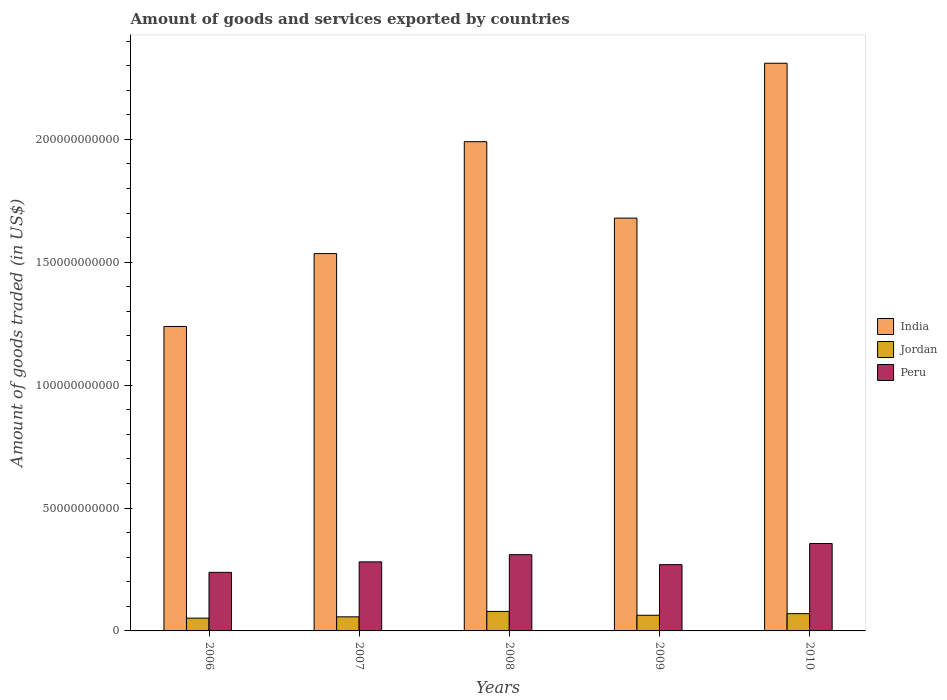How many different coloured bars are there?
Give a very brief answer. 3. Are the number of bars per tick equal to the number of legend labels?
Give a very brief answer. Yes. How many bars are there on the 3rd tick from the right?
Ensure brevity in your answer.  3. What is the label of the 1st group of bars from the left?
Give a very brief answer. 2006. What is the total amount of goods and services exported in India in 2006?
Your answer should be very brief. 1.24e+11. Across all years, what is the maximum total amount of goods and services exported in India?
Your response must be concise. 2.31e+11. Across all years, what is the minimum total amount of goods and services exported in Peru?
Make the answer very short. 2.38e+1. In which year was the total amount of goods and services exported in India maximum?
Your answer should be compact. 2010. In which year was the total amount of goods and services exported in India minimum?
Your answer should be very brief. 2006. What is the total total amount of goods and services exported in India in the graph?
Offer a terse response. 8.75e+11. What is the difference between the total amount of goods and services exported in India in 2008 and that in 2010?
Keep it short and to the point. -3.19e+1. What is the difference between the total amount of goods and services exported in Peru in 2007 and the total amount of goods and services exported in India in 2008?
Your response must be concise. -1.71e+11. What is the average total amount of goods and services exported in Jordan per year?
Provide a short and direct response. 6.46e+09. In the year 2006, what is the difference between the total amount of goods and services exported in Jordan and total amount of goods and services exported in Peru?
Give a very brief answer. -1.86e+1. In how many years, is the total amount of goods and services exported in India greater than 110000000000 US$?
Make the answer very short. 5. What is the ratio of the total amount of goods and services exported in India in 2006 to that in 2008?
Give a very brief answer. 0.62. Is the total amount of goods and services exported in India in 2006 less than that in 2010?
Offer a terse response. Yes. Is the difference between the total amount of goods and services exported in Jordan in 2006 and 2010 greater than the difference between the total amount of goods and services exported in Peru in 2006 and 2010?
Your answer should be compact. Yes. What is the difference between the highest and the second highest total amount of goods and services exported in Jordan?
Provide a succinct answer. 9.09e+08. What is the difference between the highest and the lowest total amount of goods and services exported in Jordan?
Keep it short and to the point. 2.73e+09. Is the sum of the total amount of goods and services exported in Jordan in 2006 and 2008 greater than the maximum total amount of goods and services exported in India across all years?
Offer a very short reply. No. What does the 3rd bar from the right in 2008 represents?
Keep it short and to the point. India. Is it the case that in every year, the sum of the total amount of goods and services exported in Jordan and total amount of goods and services exported in Peru is greater than the total amount of goods and services exported in India?
Ensure brevity in your answer.  No. How many bars are there?
Your response must be concise. 15. Are all the bars in the graph horizontal?
Offer a terse response. No. How many years are there in the graph?
Offer a terse response. 5. What is the difference between two consecutive major ticks on the Y-axis?
Your answer should be very brief. 5.00e+1. Where does the legend appear in the graph?
Your response must be concise. Center right. What is the title of the graph?
Keep it short and to the point. Amount of goods and services exported by countries. Does "Djibouti" appear as one of the legend labels in the graph?
Offer a very short reply. No. What is the label or title of the X-axis?
Offer a very short reply. Years. What is the label or title of the Y-axis?
Offer a very short reply. Amount of goods traded (in US$). What is the Amount of goods traded (in US$) of India in 2006?
Your response must be concise. 1.24e+11. What is the Amount of goods traded (in US$) of Jordan in 2006?
Your answer should be very brief. 5.20e+09. What is the Amount of goods traded (in US$) in Peru in 2006?
Offer a terse response. 2.38e+1. What is the Amount of goods traded (in US$) of India in 2007?
Your response must be concise. 1.54e+11. What is the Amount of goods traded (in US$) in Jordan in 2007?
Make the answer very short. 5.73e+09. What is the Amount of goods traded (in US$) in Peru in 2007?
Your answer should be compact. 2.81e+1. What is the Amount of goods traded (in US$) of India in 2008?
Your answer should be compact. 1.99e+11. What is the Amount of goods traded (in US$) of Jordan in 2008?
Provide a short and direct response. 7.94e+09. What is the Amount of goods traded (in US$) in Peru in 2008?
Provide a succinct answer. 3.10e+1. What is the Amount of goods traded (in US$) in India in 2009?
Offer a terse response. 1.68e+11. What is the Amount of goods traded (in US$) in Jordan in 2009?
Provide a short and direct response. 6.38e+09. What is the Amount of goods traded (in US$) of Peru in 2009?
Offer a very short reply. 2.70e+1. What is the Amount of goods traded (in US$) of India in 2010?
Offer a very short reply. 2.31e+11. What is the Amount of goods traded (in US$) in Jordan in 2010?
Provide a succinct answer. 7.03e+09. What is the Amount of goods traded (in US$) in Peru in 2010?
Keep it short and to the point. 3.56e+1. Across all years, what is the maximum Amount of goods traded (in US$) of India?
Your answer should be compact. 2.31e+11. Across all years, what is the maximum Amount of goods traded (in US$) of Jordan?
Offer a terse response. 7.94e+09. Across all years, what is the maximum Amount of goods traded (in US$) of Peru?
Offer a terse response. 3.56e+1. Across all years, what is the minimum Amount of goods traded (in US$) of India?
Keep it short and to the point. 1.24e+11. Across all years, what is the minimum Amount of goods traded (in US$) of Jordan?
Keep it short and to the point. 5.20e+09. Across all years, what is the minimum Amount of goods traded (in US$) in Peru?
Make the answer very short. 2.38e+1. What is the total Amount of goods traded (in US$) of India in the graph?
Offer a terse response. 8.75e+11. What is the total Amount of goods traded (in US$) of Jordan in the graph?
Your answer should be compact. 3.23e+1. What is the total Amount of goods traded (in US$) in Peru in the graph?
Keep it short and to the point. 1.45e+11. What is the difference between the Amount of goods traded (in US$) in India in 2006 and that in 2007?
Keep it short and to the point. -2.97e+1. What is the difference between the Amount of goods traded (in US$) of Jordan in 2006 and that in 2007?
Your answer should be very brief. -5.27e+08. What is the difference between the Amount of goods traded (in US$) of Peru in 2006 and that in 2007?
Provide a succinct answer. -4.26e+09. What is the difference between the Amount of goods traded (in US$) in India in 2006 and that in 2008?
Offer a terse response. -7.52e+1. What is the difference between the Amount of goods traded (in US$) of Jordan in 2006 and that in 2008?
Provide a short and direct response. -2.73e+09. What is the difference between the Amount of goods traded (in US$) of Peru in 2006 and that in 2008?
Provide a succinct answer. -7.19e+09. What is the difference between the Amount of goods traded (in US$) in India in 2006 and that in 2009?
Your response must be concise. -4.41e+1. What is the difference between the Amount of goods traded (in US$) of Jordan in 2006 and that in 2009?
Give a very brief answer. -1.17e+09. What is the difference between the Amount of goods traded (in US$) in Peru in 2006 and that in 2009?
Keep it short and to the point. -3.13e+09. What is the difference between the Amount of goods traded (in US$) of India in 2006 and that in 2010?
Offer a very short reply. -1.07e+11. What is the difference between the Amount of goods traded (in US$) of Jordan in 2006 and that in 2010?
Offer a terse response. -1.82e+09. What is the difference between the Amount of goods traded (in US$) in Peru in 2006 and that in 2010?
Provide a succinct answer. -1.17e+1. What is the difference between the Amount of goods traded (in US$) of India in 2007 and that in 2008?
Make the answer very short. -4.55e+1. What is the difference between the Amount of goods traded (in US$) of Jordan in 2007 and that in 2008?
Offer a terse response. -2.21e+09. What is the difference between the Amount of goods traded (in US$) in Peru in 2007 and that in 2008?
Keep it short and to the point. -2.92e+09. What is the difference between the Amount of goods traded (in US$) of India in 2007 and that in 2009?
Provide a short and direct response. -1.44e+1. What is the difference between the Amount of goods traded (in US$) of Jordan in 2007 and that in 2009?
Your response must be concise. -6.44e+08. What is the difference between the Amount of goods traded (in US$) in Peru in 2007 and that in 2009?
Ensure brevity in your answer.  1.13e+09. What is the difference between the Amount of goods traded (in US$) of India in 2007 and that in 2010?
Offer a terse response. -7.74e+1. What is the difference between the Amount of goods traded (in US$) of Jordan in 2007 and that in 2010?
Your answer should be compact. -1.30e+09. What is the difference between the Amount of goods traded (in US$) of Peru in 2007 and that in 2010?
Give a very brief answer. -7.47e+09. What is the difference between the Amount of goods traded (in US$) of India in 2008 and that in 2009?
Give a very brief answer. 3.11e+1. What is the difference between the Amount of goods traded (in US$) in Jordan in 2008 and that in 2009?
Ensure brevity in your answer.  1.56e+09. What is the difference between the Amount of goods traded (in US$) of Peru in 2008 and that in 2009?
Keep it short and to the point. 4.06e+09. What is the difference between the Amount of goods traded (in US$) in India in 2008 and that in 2010?
Keep it short and to the point. -3.19e+1. What is the difference between the Amount of goods traded (in US$) of Jordan in 2008 and that in 2010?
Offer a very short reply. 9.09e+08. What is the difference between the Amount of goods traded (in US$) in Peru in 2008 and that in 2010?
Your answer should be very brief. -4.55e+09. What is the difference between the Amount of goods traded (in US$) of India in 2009 and that in 2010?
Keep it short and to the point. -6.30e+1. What is the difference between the Amount of goods traded (in US$) in Jordan in 2009 and that in 2010?
Keep it short and to the point. -6.53e+08. What is the difference between the Amount of goods traded (in US$) of Peru in 2009 and that in 2010?
Provide a short and direct response. -8.60e+09. What is the difference between the Amount of goods traded (in US$) in India in 2006 and the Amount of goods traded (in US$) in Jordan in 2007?
Provide a short and direct response. 1.18e+11. What is the difference between the Amount of goods traded (in US$) of India in 2006 and the Amount of goods traded (in US$) of Peru in 2007?
Offer a very short reply. 9.58e+1. What is the difference between the Amount of goods traded (in US$) of Jordan in 2006 and the Amount of goods traded (in US$) of Peru in 2007?
Your answer should be very brief. -2.29e+1. What is the difference between the Amount of goods traded (in US$) of India in 2006 and the Amount of goods traded (in US$) of Jordan in 2008?
Offer a terse response. 1.16e+11. What is the difference between the Amount of goods traded (in US$) in India in 2006 and the Amount of goods traded (in US$) in Peru in 2008?
Your answer should be very brief. 9.29e+1. What is the difference between the Amount of goods traded (in US$) in Jordan in 2006 and the Amount of goods traded (in US$) in Peru in 2008?
Give a very brief answer. -2.58e+1. What is the difference between the Amount of goods traded (in US$) of India in 2006 and the Amount of goods traded (in US$) of Jordan in 2009?
Provide a short and direct response. 1.18e+11. What is the difference between the Amount of goods traded (in US$) of India in 2006 and the Amount of goods traded (in US$) of Peru in 2009?
Provide a succinct answer. 9.69e+1. What is the difference between the Amount of goods traded (in US$) of Jordan in 2006 and the Amount of goods traded (in US$) of Peru in 2009?
Provide a short and direct response. -2.18e+1. What is the difference between the Amount of goods traded (in US$) in India in 2006 and the Amount of goods traded (in US$) in Jordan in 2010?
Your response must be concise. 1.17e+11. What is the difference between the Amount of goods traded (in US$) of India in 2006 and the Amount of goods traded (in US$) of Peru in 2010?
Offer a terse response. 8.83e+1. What is the difference between the Amount of goods traded (in US$) in Jordan in 2006 and the Amount of goods traded (in US$) in Peru in 2010?
Make the answer very short. -3.04e+1. What is the difference between the Amount of goods traded (in US$) of India in 2007 and the Amount of goods traded (in US$) of Jordan in 2008?
Make the answer very short. 1.46e+11. What is the difference between the Amount of goods traded (in US$) of India in 2007 and the Amount of goods traded (in US$) of Peru in 2008?
Give a very brief answer. 1.23e+11. What is the difference between the Amount of goods traded (in US$) in Jordan in 2007 and the Amount of goods traded (in US$) in Peru in 2008?
Give a very brief answer. -2.53e+1. What is the difference between the Amount of goods traded (in US$) in India in 2007 and the Amount of goods traded (in US$) in Jordan in 2009?
Provide a succinct answer. 1.47e+11. What is the difference between the Amount of goods traded (in US$) of India in 2007 and the Amount of goods traded (in US$) of Peru in 2009?
Give a very brief answer. 1.27e+11. What is the difference between the Amount of goods traded (in US$) in Jordan in 2007 and the Amount of goods traded (in US$) in Peru in 2009?
Your response must be concise. -2.12e+1. What is the difference between the Amount of goods traded (in US$) of India in 2007 and the Amount of goods traded (in US$) of Jordan in 2010?
Your answer should be compact. 1.47e+11. What is the difference between the Amount of goods traded (in US$) of India in 2007 and the Amount of goods traded (in US$) of Peru in 2010?
Provide a short and direct response. 1.18e+11. What is the difference between the Amount of goods traded (in US$) in Jordan in 2007 and the Amount of goods traded (in US$) in Peru in 2010?
Offer a very short reply. -2.98e+1. What is the difference between the Amount of goods traded (in US$) in India in 2008 and the Amount of goods traded (in US$) in Jordan in 2009?
Provide a short and direct response. 1.93e+11. What is the difference between the Amount of goods traded (in US$) of India in 2008 and the Amount of goods traded (in US$) of Peru in 2009?
Provide a short and direct response. 1.72e+11. What is the difference between the Amount of goods traded (in US$) of Jordan in 2008 and the Amount of goods traded (in US$) of Peru in 2009?
Your answer should be very brief. -1.90e+1. What is the difference between the Amount of goods traded (in US$) of India in 2008 and the Amount of goods traded (in US$) of Jordan in 2010?
Make the answer very short. 1.92e+11. What is the difference between the Amount of goods traded (in US$) of India in 2008 and the Amount of goods traded (in US$) of Peru in 2010?
Make the answer very short. 1.64e+11. What is the difference between the Amount of goods traded (in US$) in Jordan in 2008 and the Amount of goods traded (in US$) in Peru in 2010?
Your answer should be very brief. -2.76e+1. What is the difference between the Amount of goods traded (in US$) in India in 2009 and the Amount of goods traded (in US$) in Jordan in 2010?
Ensure brevity in your answer.  1.61e+11. What is the difference between the Amount of goods traded (in US$) in India in 2009 and the Amount of goods traded (in US$) in Peru in 2010?
Make the answer very short. 1.32e+11. What is the difference between the Amount of goods traded (in US$) of Jordan in 2009 and the Amount of goods traded (in US$) of Peru in 2010?
Offer a terse response. -2.92e+1. What is the average Amount of goods traded (in US$) of India per year?
Give a very brief answer. 1.75e+11. What is the average Amount of goods traded (in US$) in Jordan per year?
Your answer should be compact. 6.46e+09. What is the average Amount of goods traded (in US$) of Peru per year?
Give a very brief answer. 2.91e+1. In the year 2006, what is the difference between the Amount of goods traded (in US$) in India and Amount of goods traded (in US$) in Jordan?
Provide a short and direct response. 1.19e+11. In the year 2006, what is the difference between the Amount of goods traded (in US$) of India and Amount of goods traded (in US$) of Peru?
Your answer should be very brief. 1.00e+11. In the year 2006, what is the difference between the Amount of goods traded (in US$) of Jordan and Amount of goods traded (in US$) of Peru?
Provide a short and direct response. -1.86e+1. In the year 2007, what is the difference between the Amount of goods traded (in US$) in India and Amount of goods traded (in US$) in Jordan?
Offer a very short reply. 1.48e+11. In the year 2007, what is the difference between the Amount of goods traded (in US$) in India and Amount of goods traded (in US$) in Peru?
Offer a terse response. 1.25e+11. In the year 2007, what is the difference between the Amount of goods traded (in US$) of Jordan and Amount of goods traded (in US$) of Peru?
Provide a short and direct response. -2.24e+1. In the year 2008, what is the difference between the Amount of goods traded (in US$) of India and Amount of goods traded (in US$) of Jordan?
Your answer should be compact. 1.91e+11. In the year 2008, what is the difference between the Amount of goods traded (in US$) in India and Amount of goods traded (in US$) in Peru?
Keep it short and to the point. 1.68e+11. In the year 2008, what is the difference between the Amount of goods traded (in US$) in Jordan and Amount of goods traded (in US$) in Peru?
Offer a terse response. -2.31e+1. In the year 2009, what is the difference between the Amount of goods traded (in US$) in India and Amount of goods traded (in US$) in Jordan?
Provide a short and direct response. 1.62e+11. In the year 2009, what is the difference between the Amount of goods traded (in US$) of India and Amount of goods traded (in US$) of Peru?
Provide a short and direct response. 1.41e+11. In the year 2009, what is the difference between the Amount of goods traded (in US$) of Jordan and Amount of goods traded (in US$) of Peru?
Your answer should be compact. -2.06e+1. In the year 2010, what is the difference between the Amount of goods traded (in US$) of India and Amount of goods traded (in US$) of Jordan?
Offer a terse response. 2.24e+11. In the year 2010, what is the difference between the Amount of goods traded (in US$) in India and Amount of goods traded (in US$) in Peru?
Your answer should be very brief. 1.95e+11. In the year 2010, what is the difference between the Amount of goods traded (in US$) of Jordan and Amount of goods traded (in US$) of Peru?
Ensure brevity in your answer.  -2.85e+1. What is the ratio of the Amount of goods traded (in US$) in India in 2006 to that in 2007?
Give a very brief answer. 0.81. What is the ratio of the Amount of goods traded (in US$) of Jordan in 2006 to that in 2007?
Keep it short and to the point. 0.91. What is the ratio of the Amount of goods traded (in US$) of Peru in 2006 to that in 2007?
Offer a terse response. 0.85. What is the ratio of the Amount of goods traded (in US$) of India in 2006 to that in 2008?
Your response must be concise. 0.62. What is the ratio of the Amount of goods traded (in US$) in Jordan in 2006 to that in 2008?
Make the answer very short. 0.66. What is the ratio of the Amount of goods traded (in US$) in Peru in 2006 to that in 2008?
Make the answer very short. 0.77. What is the ratio of the Amount of goods traded (in US$) of India in 2006 to that in 2009?
Give a very brief answer. 0.74. What is the ratio of the Amount of goods traded (in US$) in Jordan in 2006 to that in 2009?
Provide a succinct answer. 0.82. What is the ratio of the Amount of goods traded (in US$) in Peru in 2006 to that in 2009?
Your response must be concise. 0.88. What is the ratio of the Amount of goods traded (in US$) in India in 2006 to that in 2010?
Make the answer very short. 0.54. What is the ratio of the Amount of goods traded (in US$) in Jordan in 2006 to that in 2010?
Your answer should be very brief. 0.74. What is the ratio of the Amount of goods traded (in US$) of Peru in 2006 to that in 2010?
Your answer should be compact. 0.67. What is the ratio of the Amount of goods traded (in US$) of India in 2007 to that in 2008?
Offer a very short reply. 0.77. What is the ratio of the Amount of goods traded (in US$) of Jordan in 2007 to that in 2008?
Your answer should be compact. 0.72. What is the ratio of the Amount of goods traded (in US$) of Peru in 2007 to that in 2008?
Provide a short and direct response. 0.91. What is the ratio of the Amount of goods traded (in US$) of India in 2007 to that in 2009?
Provide a short and direct response. 0.91. What is the ratio of the Amount of goods traded (in US$) of Jordan in 2007 to that in 2009?
Offer a terse response. 0.9. What is the ratio of the Amount of goods traded (in US$) of Peru in 2007 to that in 2009?
Offer a terse response. 1.04. What is the ratio of the Amount of goods traded (in US$) of India in 2007 to that in 2010?
Your response must be concise. 0.66. What is the ratio of the Amount of goods traded (in US$) of Jordan in 2007 to that in 2010?
Offer a terse response. 0.82. What is the ratio of the Amount of goods traded (in US$) in Peru in 2007 to that in 2010?
Ensure brevity in your answer.  0.79. What is the ratio of the Amount of goods traded (in US$) of India in 2008 to that in 2009?
Provide a succinct answer. 1.19. What is the ratio of the Amount of goods traded (in US$) in Jordan in 2008 to that in 2009?
Keep it short and to the point. 1.25. What is the ratio of the Amount of goods traded (in US$) of Peru in 2008 to that in 2009?
Keep it short and to the point. 1.15. What is the ratio of the Amount of goods traded (in US$) of India in 2008 to that in 2010?
Offer a terse response. 0.86. What is the ratio of the Amount of goods traded (in US$) in Jordan in 2008 to that in 2010?
Keep it short and to the point. 1.13. What is the ratio of the Amount of goods traded (in US$) in Peru in 2008 to that in 2010?
Provide a short and direct response. 0.87. What is the ratio of the Amount of goods traded (in US$) of India in 2009 to that in 2010?
Make the answer very short. 0.73. What is the ratio of the Amount of goods traded (in US$) in Jordan in 2009 to that in 2010?
Your answer should be very brief. 0.91. What is the ratio of the Amount of goods traded (in US$) of Peru in 2009 to that in 2010?
Ensure brevity in your answer.  0.76. What is the difference between the highest and the second highest Amount of goods traded (in US$) of India?
Ensure brevity in your answer.  3.19e+1. What is the difference between the highest and the second highest Amount of goods traded (in US$) of Jordan?
Offer a terse response. 9.09e+08. What is the difference between the highest and the second highest Amount of goods traded (in US$) of Peru?
Give a very brief answer. 4.55e+09. What is the difference between the highest and the lowest Amount of goods traded (in US$) in India?
Offer a terse response. 1.07e+11. What is the difference between the highest and the lowest Amount of goods traded (in US$) in Jordan?
Offer a very short reply. 2.73e+09. What is the difference between the highest and the lowest Amount of goods traded (in US$) in Peru?
Your answer should be very brief. 1.17e+1. 